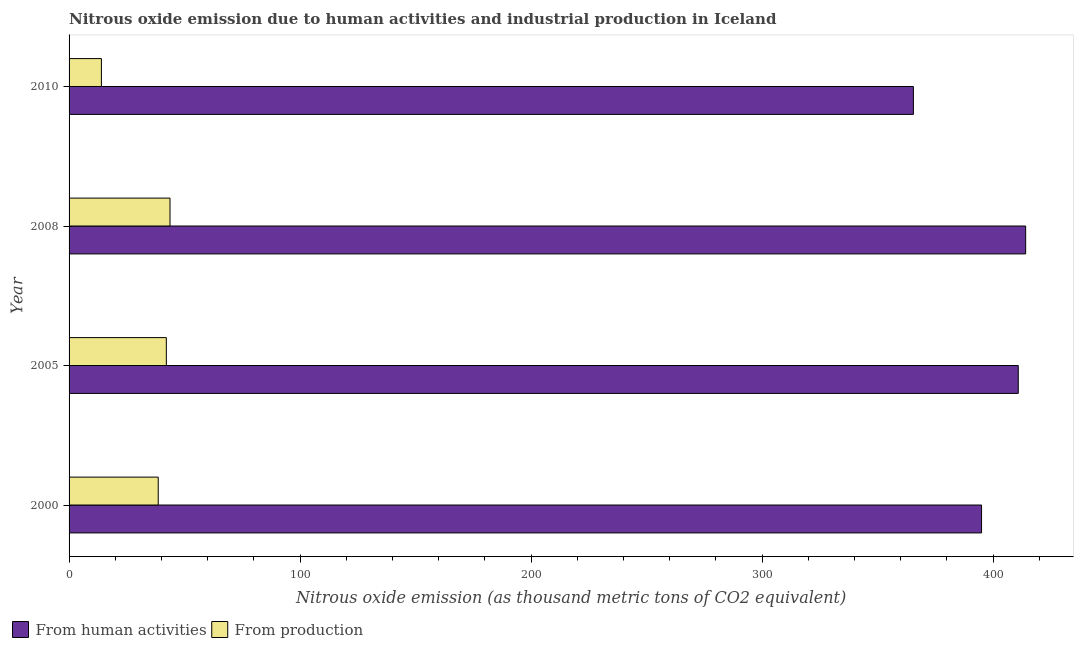How many groups of bars are there?
Make the answer very short. 4. Are the number of bars per tick equal to the number of legend labels?
Keep it short and to the point. Yes. What is the amount of emissions generated from industries in 2000?
Keep it short and to the point. 38.6. Across all years, what is the maximum amount of emissions from human activities?
Offer a very short reply. 414.1. Across all years, what is the minimum amount of emissions from human activities?
Make the answer very short. 365.5. What is the total amount of emissions from human activities in the graph?
Your answer should be very brief. 1585.5. What is the difference between the amount of emissions generated from industries in 2000 and the amount of emissions from human activities in 2010?
Offer a very short reply. -326.9. What is the average amount of emissions generated from industries per year?
Make the answer very short. 34.6. In the year 2000, what is the difference between the amount of emissions from human activities and amount of emissions generated from industries?
Your response must be concise. 356.4. In how many years, is the amount of emissions from human activities greater than 320 thousand metric tons?
Offer a terse response. 4. What is the ratio of the amount of emissions from human activities in 2005 to that in 2010?
Provide a short and direct response. 1.12. Is the difference between the amount of emissions from human activities in 2000 and 2005 greater than the difference between the amount of emissions generated from industries in 2000 and 2005?
Your answer should be very brief. No. What is the difference between the highest and the second highest amount of emissions generated from industries?
Your answer should be compact. 1.6. What is the difference between the highest and the lowest amount of emissions generated from industries?
Your answer should be very brief. 29.7. Is the sum of the amount of emissions from human activities in 2008 and 2010 greater than the maximum amount of emissions generated from industries across all years?
Your response must be concise. Yes. What does the 1st bar from the top in 2005 represents?
Ensure brevity in your answer.  From production. What does the 1st bar from the bottom in 2008 represents?
Offer a very short reply. From human activities. How many bars are there?
Make the answer very short. 8. What is the difference between two consecutive major ticks on the X-axis?
Offer a very short reply. 100. Does the graph contain any zero values?
Offer a terse response. No. Does the graph contain grids?
Your answer should be compact. No. Where does the legend appear in the graph?
Your answer should be compact. Bottom left. How are the legend labels stacked?
Make the answer very short. Horizontal. What is the title of the graph?
Ensure brevity in your answer.  Nitrous oxide emission due to human activities and industrial production in Iceland. Does "Lower secondary education" appear as one of the legend labels in the graph?
Your answer should be compact. No. What is the label or title of the X-axis?
Offer a very short reply. Nitrous oxide emission (as thousand metric tons of CO2 equivalent). What is the Nitrous oxide emission (as thousand metric tons of CO2 equivalent) of From human activities in 2000?
Your answer should be compact. 395. What is the Nitrous oxide emission (as thousand metric tons of CO2 equivalent) of From production in 2000?
Offer a terse response. 38.6. What is the Nitrous oxide emission (as thousand metric tons of CO2 equivalent) of From human activities in 2005?
Your response must be concise. 410.9. What is the Nitrous oxide emission (as thousand metric tons of CO2 equivalent) in From production in 2005?
Your answer should be very brief. 42.1. What is the Nitrous oxide emission (as thousand metric tons of CO2 equivalent) of From human activities in 2008?
Your answer should be very brief. 414.1. What is the Nitrous oxide emission (as thousand metric tons of CO2 equivalent) of From production in 2008?
Your answer should be very brief. 43.7. What is the Nitrous oxide emission (as thousand metric tons of CO2 equivalent) of From human activities in 2010?
Your answer should be very brief. 365.5. Across all years, what is the maximum Nitrous oxide emission (as thousand metric tons of CO2 equivalent) in From human activities?
Provide a short and direct response. 414.1. Across all years, what is the maximum Nitrous oxide emission (as thousand metric tons of CO2 equivalent) in From production?
Your answer should be very brief. 43.7. Across all years, what is the minimum Nitrous oxide emission (as thousand metric tons of CO2 equivalent) in From human activities?
Make the answer very short. 365.5. What is the total Nitrous oxide emission (as thousand metric tons of CO2 equivalent) of From human activities in the graph?
Make the answer very short. 1585.5. What is the total Nitrous oxide emission (as thousand metric tons of CO2 equivalent) of From production in the graph?
Ensure brevity in your answer.  138.4. What is the difference between the Nitrous oxide emission (as thousand metric tons of CO2 equivalent) of From human activities in 2000 and that in 2005?
Offer a very short reply. -15.9. What is the difference between the Nitrous oxide emission (as thousand metric tons of CO2 equivalent) in From production in 2000 and that in 2005?
Make the answer very short. -3.5. What is the difference between the Nitrous oxide emission (as thousand metric tons of CO2 equivalent) in From human activities in 2000 and that in 2008?
Your response must be concise. -19.1. What is the difference between the Nitrous oxide emission (as thousand metric tons of CO2 equivalent) in From production in 2000 and that in 2008?
Keep it short and to the point. -5.1. What is the difference between the Nitrous oxide emission (as thousand metric tons of CO2 equivalent) in From human activities in 2000 and that in 2010?
Give a very brief answer. 29.5. What is the difference between the Nitrous oxide emission (as thousand metric tons of CO2 equivalent) of From production in 2000 and that in 2010?
Keep it short and to the point. 24.6. What is the difference between the Nitrous oxide emission (as thousand metric tons of CO2 equivalent) of From production in 2005 and that in 2008?
Your response must be concise. -1.6. What is the difference between the Nitrous oxide emission (as thousand metric tons of CO2 equivalent) of From human activities in 2005 and that in 2010?
Keep it short and to the point. 45.4. What is the difference between the Nitrous oxide emission (as thousand metric tons of CO2 equivalent) of From production in 2005 and that in 2010?
Offer a very short reply. 28.1. What is the difference between the Nitrous oxide emission (as thousand metric tons of CO2 equivalent) in From human activities in 2008 and that in 2010?
Your answer should be very brief. 48.6. What is the difference between the Nitrous oxide emission (as thousand metric tons of CO2 equivalent) in From production in 2008 and that in 2010?
Provide a succinct answer. 29.7. What is the difference between the Nitrous oxide emission (as thousand metric tons of CO2 equivalent) in From human activities in 2000 and the Nitrous oxide emission (as thousand metric tons of CO2 equivalent) in From production in 2005?
Provide a short and direct response. 352.9. What is the difference between the Nitrous oxide emission (as thousand metric tons of CO2 equivalent) in From human activities in 2000 and the Nitrous oxide emission (as thousand metric tons of CO2 equivalent) in From production in 2008?
Provide a short and direct response. 351.3. What is the difference between the Nitrous oxide emission (as thousand metric tons of CO2 equivalent) in From human activities in 2000 and the Nitrous oxide emission (as thousand metric tons of CO2 equivalent) in From production in 2010?
Keep it short and to the point. 381. What is the difference between the Nitrous oxide emission (as thousand metric tons of CO2 equivalent) of From human activities in 2005 and the Nitrous oxide emission (as thousand metric tons of CO2 equivalent) of From production in 2008?
Your answer should be very brief. 367.2. What is the difference between the Nitrous oxide emission (as thousand metric tons of CO2 equivalent) of From human activities in 2005 and the Nitrous oxide emission (as thousand metric tons of CO2 equivalent) of From production in 2010?
Your answer should be very brief. 396.9. What is the difference between the Nitrous oxide emission (as thousand metric tons of CO2 equivalent) of From human activities in 2008 and the Nitrous oxide emission (as thousand metric tons of CO2 equivalent) of From production in 2010?
Your answer should be compact. 400.1. What is the average Nitrous oxide emission (as thousand metric tons of CO2 equivalent) in From human activities per year?
Make the answer very short. 396.38. What is the average Nitrous oxide emission (as thousand metric tons of CO2 equivalent) of From production per year?
Your response must be concise. 34.6. In the year 2000, what is the difference between the Nitrous oxide emission (as thousand metric tons of CO2 equivalent) in From human activities and Nitrous oxide emission (as thousand metric tons of CO2 equivalent) in From production?
Your answer should be very brief. 356.4. In the year 2005, what is the difference between the Nitrous oxide emission (as thousand metric tons of CO2 equivalent) of From human activities and Nitrous oxide emission (as thousand metric tons of CO2 equivalent) of From production?
Keep it short and to the point. 368.8. In the year 2008, what is the difference between the Nitrous oxide emission (as thousand metric tons of CO2 equivalent) of From human activities and Nitrous oxide emission (as thousand metric tons of CO2 equivalent) of From production?
Ensure brevity in your answer.  370.4. In the year 2010, what is the difference between the Nitrous oxide emission (as thousand metric tons of CO2 equivalent) of From human activities and Nitrous oxide emission (as thousand metric tons of CO2 equivalent) of From production?
Keep it short and to the point. 351.5. What is the ratio of the Nitrous oxide emission (as thousand metric tons of CO2 equivalent) of From human activities in 2000 to that in 2005?
Your response must be concise. 0.96. What is the ratio of the Nitrous oxide emission (as thousand metric tons of CO2 equivalent) in From production in 2000 to that in 2005?
Your answer should be compact. 0.92. What is the ratio of the Nitrous oxide emission (as thousand metric tons of CO2 equivalent) of From human activities in 2000 to that in 2008?
Your answer should be very brief. 0.95. What is the ratio of the Nitrous oxide emission (as thousand metric tons of CO2 equivalent) in From production in 2000 to that in 2008?
Your response must be concise. 0.88. What is the ratio of the Nitrous oxide emission (as thousand metric tons of CO2 equivalent) in From human activities in 2000 to that in 2010?
Give a very brief answer. 1.08. What is the ratio of the Nitrous oxide emission (as thousand metric tons of CO2 equivalent) of From production in 2000 to that in 2010?
Provide a short and direct response. 2.76. What is the ratio of the Nitrous oxide emission (as thousand metric tons of CO2 equivalent) of From human activities in 2005 to that in 2008?
Provide a short and direct response. 0.99. What is the ratio of the Nitrous oxide emission (as thousand metric tons of CO2 equivalent) of From production in 2005 to that in 2008?
Give a very brief answer. 0.96. What is the ratio of the Nitrous oxide emission (as thousand metric tons of CO2 equivalent) of From human activities in 2005 to that in 2010?
Provide a short and direct response. 1.12. What is the ratio of the Nitrous oxide emission (as thousand metric tons of CO2 equivalent) in From production in 2005 to that in 2010?
Your response must be concise. 3.01. What is the ratio of the Nitrous oxide emission (as thousand metric tons of CO2 equivalent) of From human activities in 2008 to that in 2010?
Your response must be concise. 1.13. What is the ratio of the Nitrous oxide emission (as thousand metric tons of CO2 equivalent) in From production in 2008 to that in 2010?
Ensure brevity in your answer.  3.12. What is the difference between the highest and the second highest Nitrous oxide emission (as thousand metric tons of CO2 equivalent) in From production?
Provide a succinct answer. 1.6. What is the difference between the highest and the lowest Nitrous oxide emission (as thousand metric tons of CO2 equivalent) of From human activities?
Your answer should be very brief. 48.6. What is the difference between the highest and the lowest Nitrous oxide emission (as thousand metric tons of CO2 equivalent) of From production?
Ensure brevity in your answer.  29.7. 